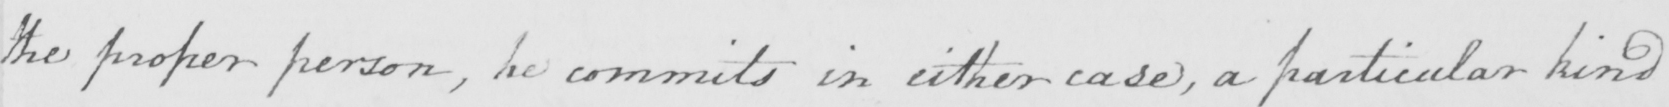Can you tell me what this handwritten text says? the proper person , he commits in either case , a particular kind 